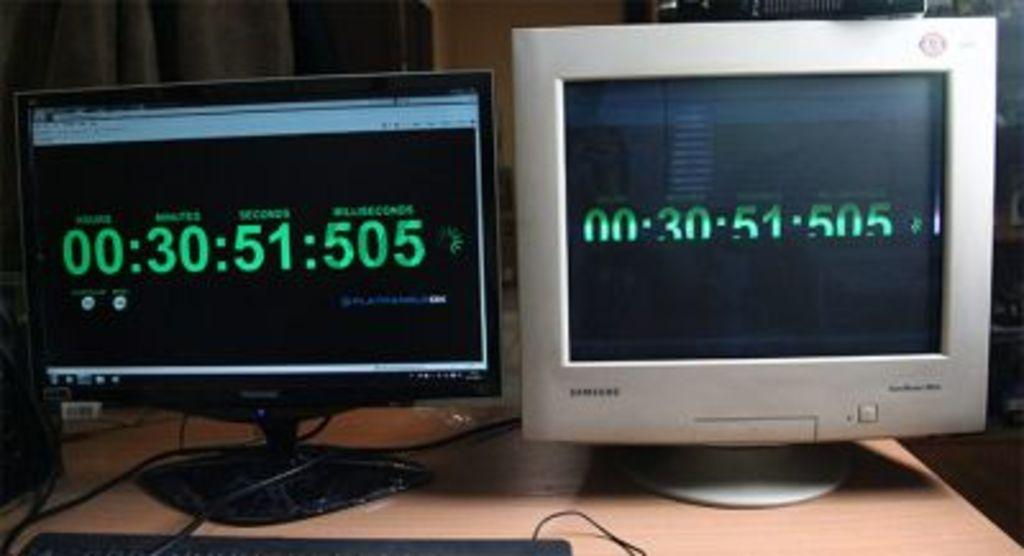<image>
Give a short and clear explanation of the subsequent image. Two monitors are showing a type of numeric display with the last numbers being 505. 